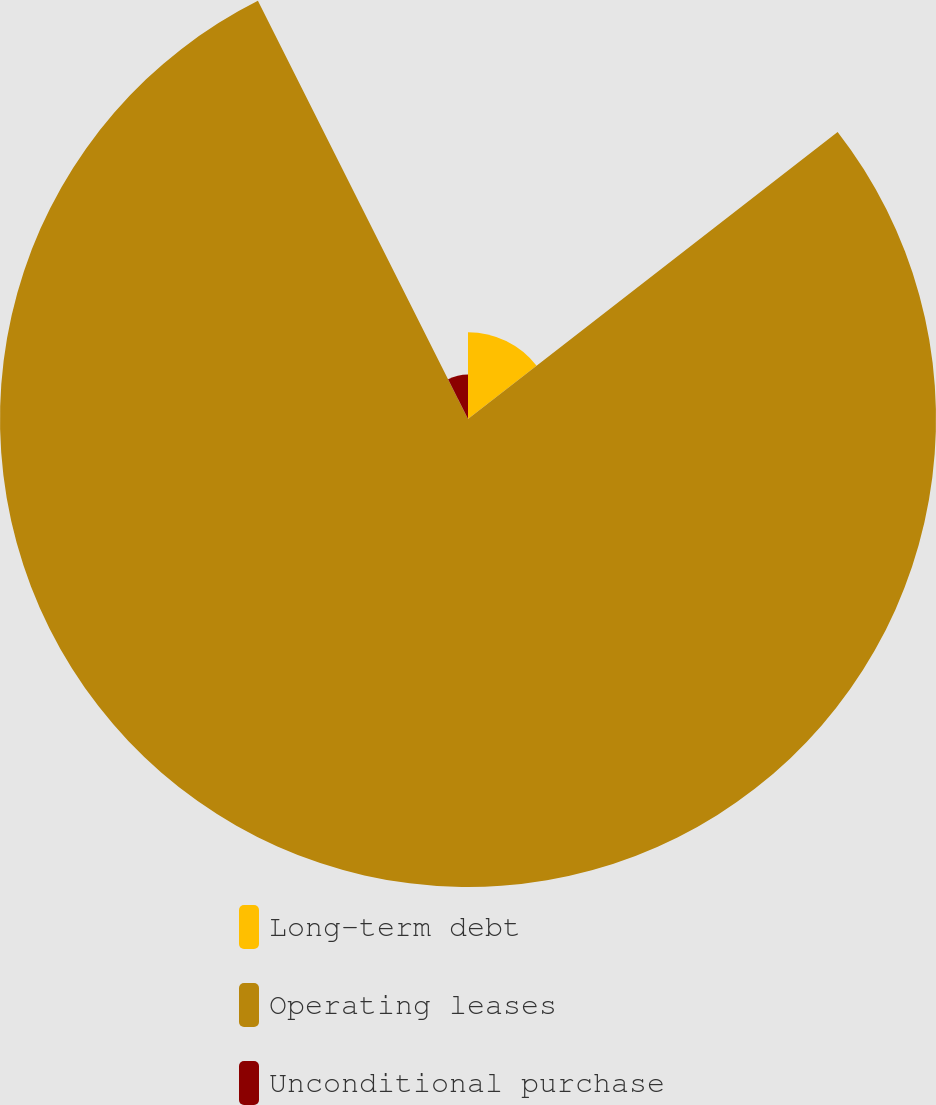Convert chart. <chart><loc_0><loc_0><loc_500><loc_500><pie_chart><fcel>Long-term debt<fcel>Operating leases<fcel>Unconditional purchase<nl><fcel>14.49%<fcel>78.1%<fcel>7.41%<nl></chart> 